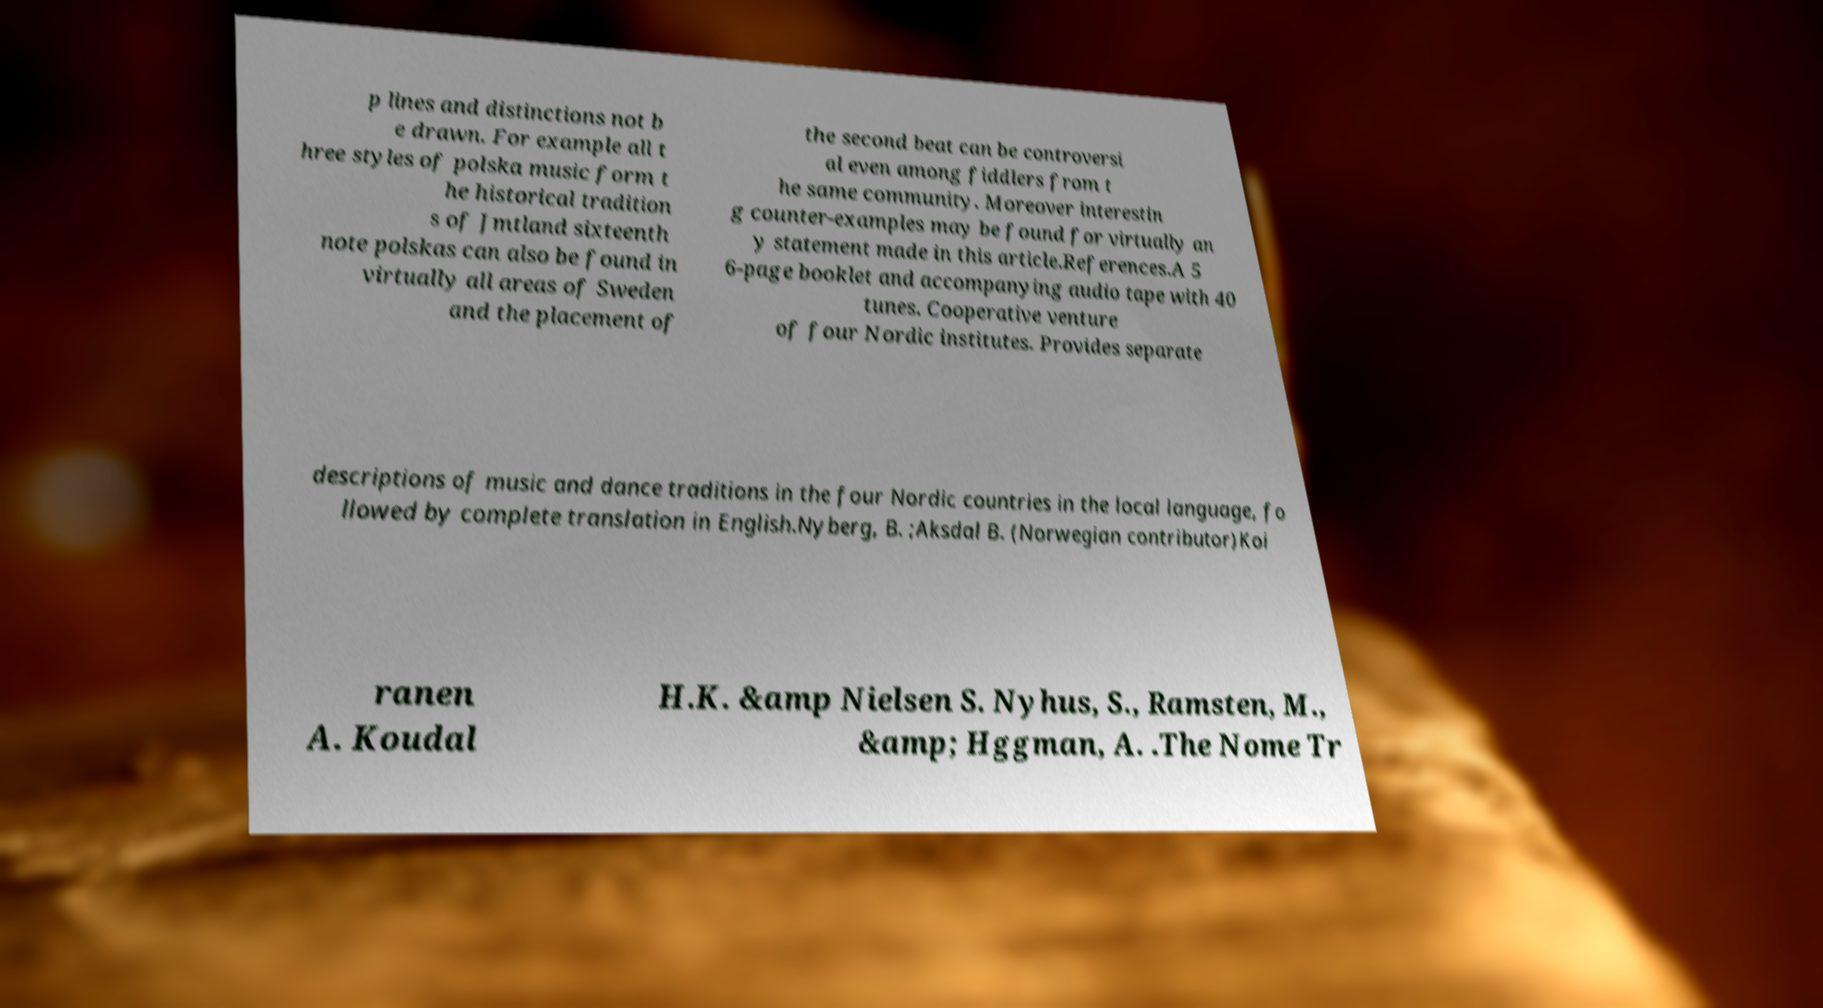Please read and relay the text visible in this image. What does it say? p lines and distinctions not b e drawn. For example all t hree styles of polska music form t he historical tradition s of Jmtland sixteenth note polskas can also be found in virtually all areas of Sweden and the placement of the second beat can be controversi al even among fiddlers from t he same community. Moreover interestin g counter-examples may be found for virtually an y statement made in this article.References.A 5 6-page booklet and accompanying audio tape with 40 tunes. Cooperative venture of four Nordic institutes. Provides separate descriptions of music and dance traditions in the four Nordic countries in the local language, fo llowed by complete translation in English.Nyberg, B. ;Aksdal B. (Norwegian contributor)Koi ranen A. Koudal H.K. &amp Nielsen S. Nyhus, S., Ramsten, M., &amp; Hggman, A. .The Nome Tr 